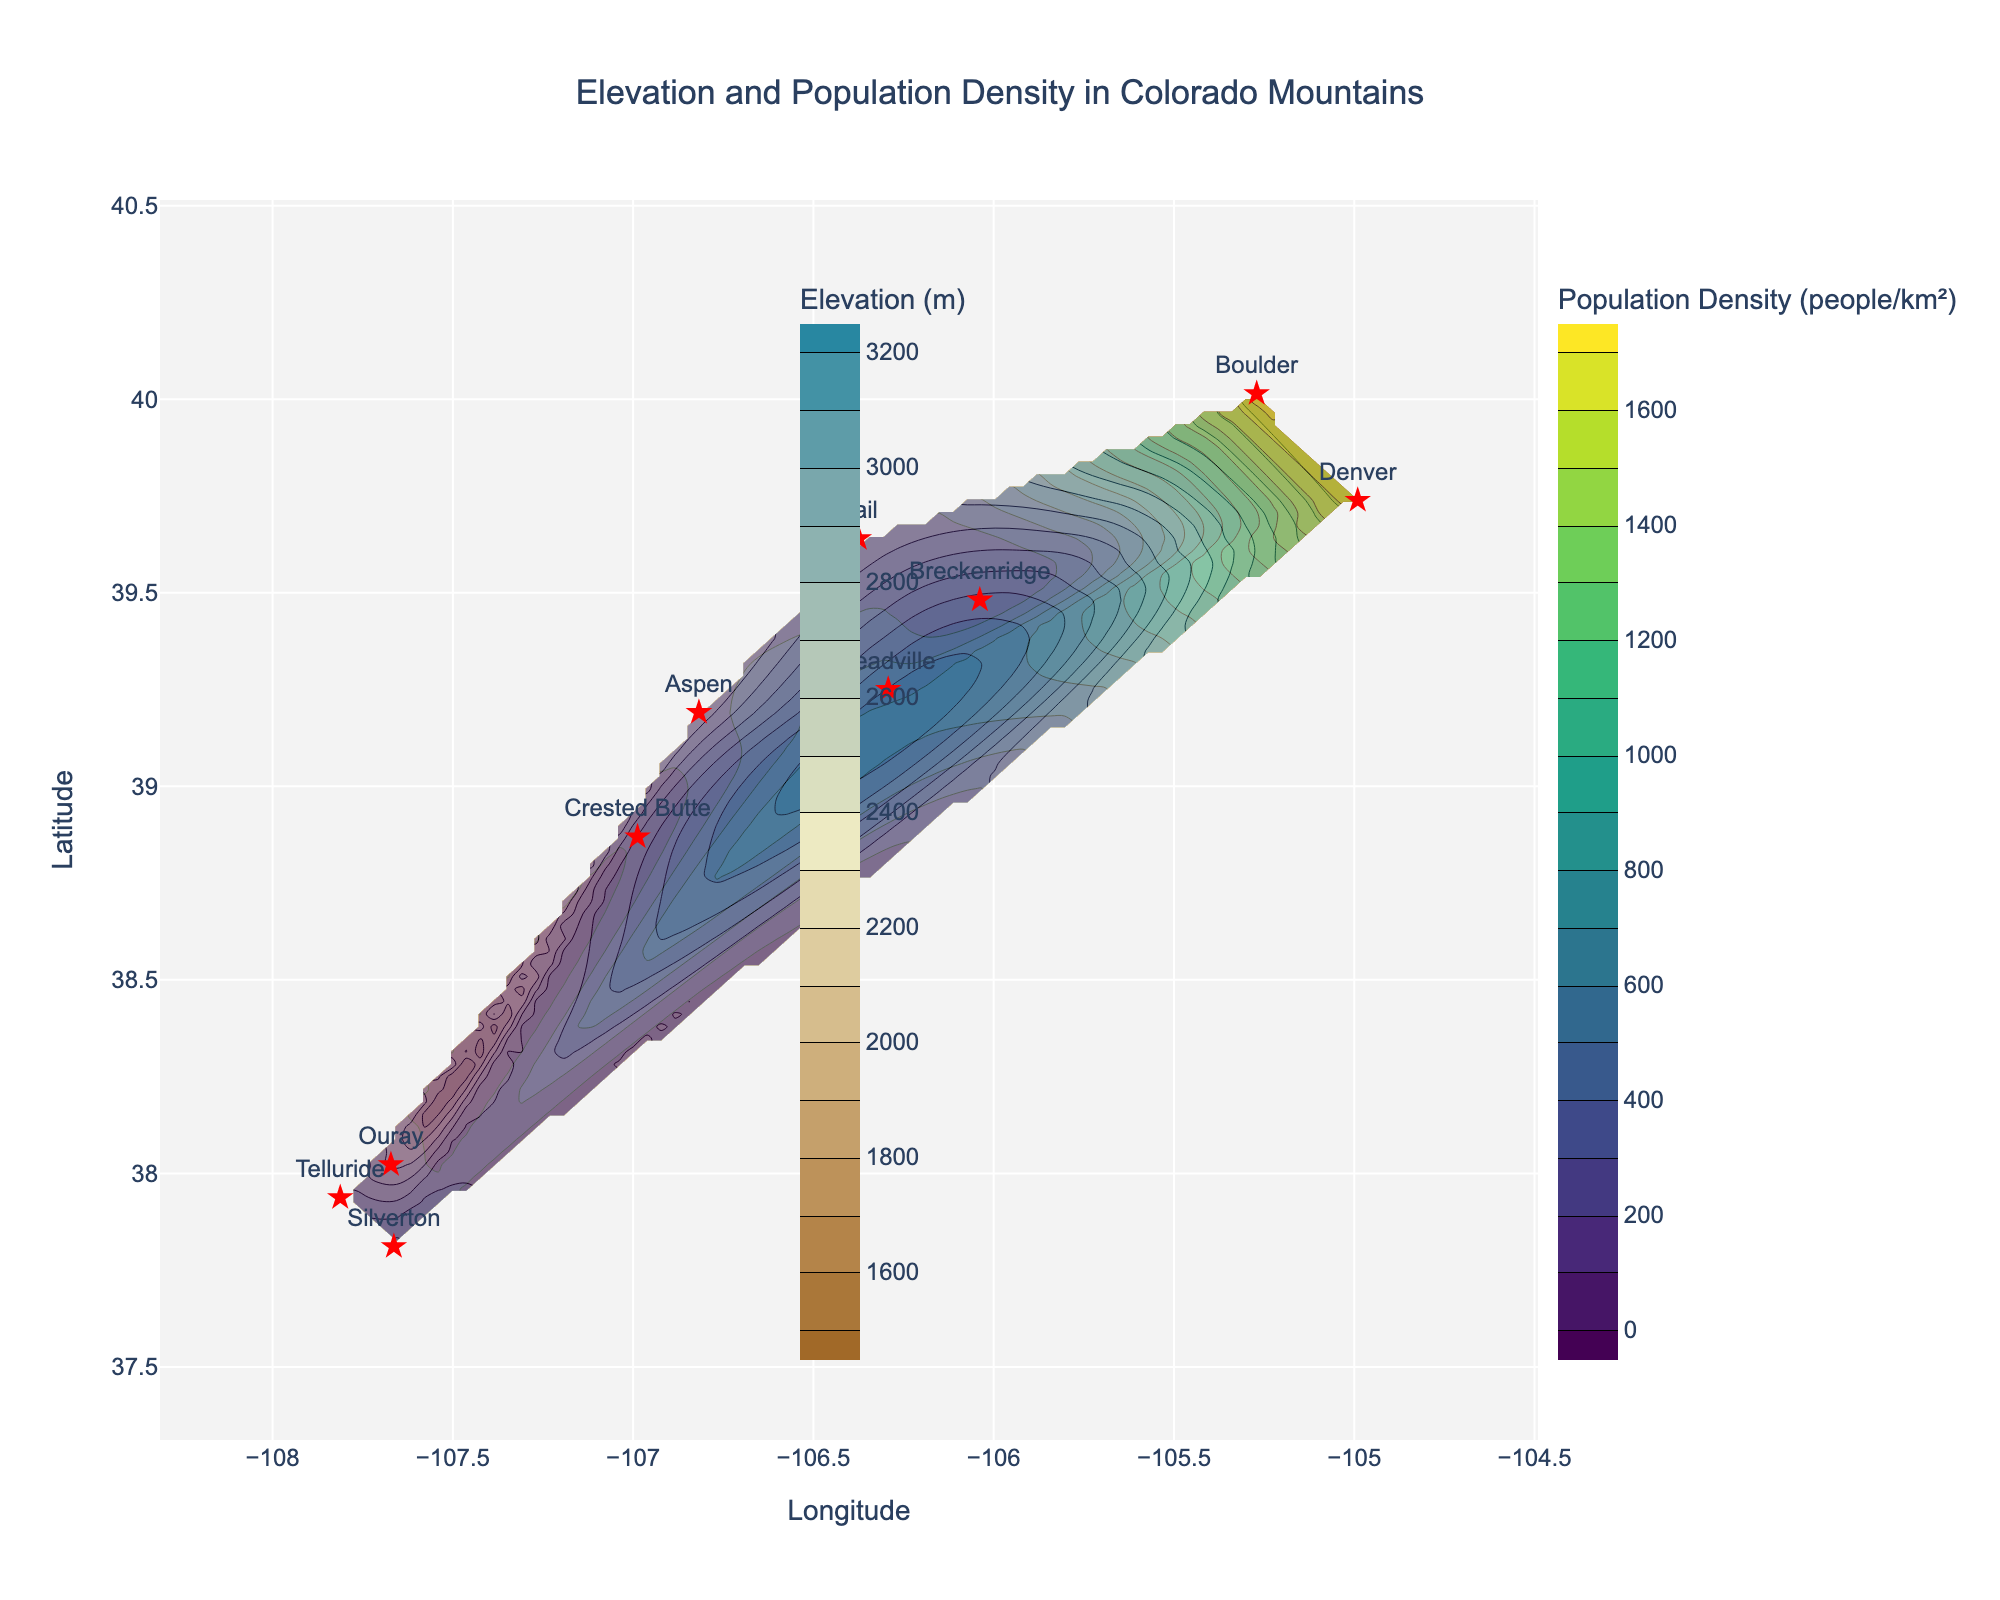What is the title of the figure? The title of the figure is usually located at the top center of the plot in a larger and bold font. In this case, it reads 'Elevation and Population Density in Colorado Mountains'.
Answer: Elevation and Population Density in Colorado Mountains Which color scale represents elevation on the plot? The figure uses color scales to differentiate between elevation and population density. The elevation is represented by the 'Earth' color scale.
Answer: Earth What is the longitude range covered in the plot? By observing the x-axis, the longitude range covered in the plot is from approximately -108 to -104 degrees.
Answer: -108 to -104 Which city has the highest elevation? The scatter plot marks the cities, and we can see their elevations in the contour plot. Leadville is marked and positioned near the highest elevation contour lines.
Answer: Leadville In which region of the plot is the population density highest? By looking at the color scale and the contours for population density, we can see the highest density in the Northeast quadrant of the plot.
Answer: Northeast quadrant How does the elevation typically change from Denver to Silverton? Denver is located at a lower elevation (around 1609 m) compared to Silverton (around 2835 m). This can be seen from the contour lines which show elevation increasing as you move from Denver to Silverton.
Answer: Increases Which city has the lowest population density? Silverton has the lowest population density, marked by the smallest contour intervals in the population density layer.
Answer: Silverton Comparing Boulder and Aspen, which city has a higher population density and by how much? Boulder’s population density is 1660 people/km², while Aspen’s is 168 people/km². The difference in population density is 1660 - 168 = 1492 people/km².
Answer: Boulder by 1492 people/km² What is the relationship between elevation and population density in this plot? From the contour plot, we observe that regions with higher elevations tend to have lower population densities. This is evidenced by the inverse correlation between the populated areas and elevation lines.
Answer: Higher elevation areas have lower population densities Approximately what is the range of population density seen on the plot? By checking the contour lines and the color bar for population density, the density ranges from around 0 to 1700 people per km².
Answer: 0 to 1700 people/km² 